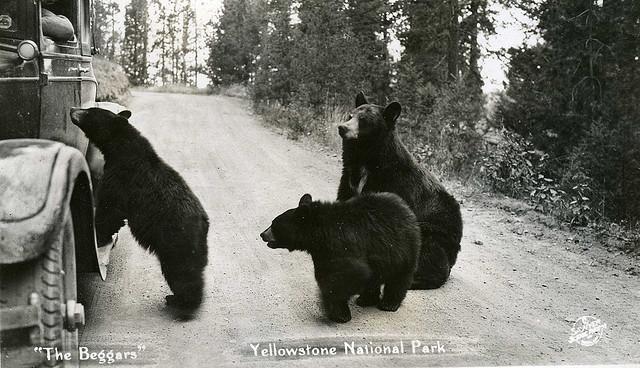What color are the bears?
Keep it brief. Black. Are the bears free?
Concise answer only. Yes. Is the photo  colorful?
Give a very brief answer. No. How many bears in this photo?
Short answer required. 3. Are the bears eating?
Be succinct. No. 